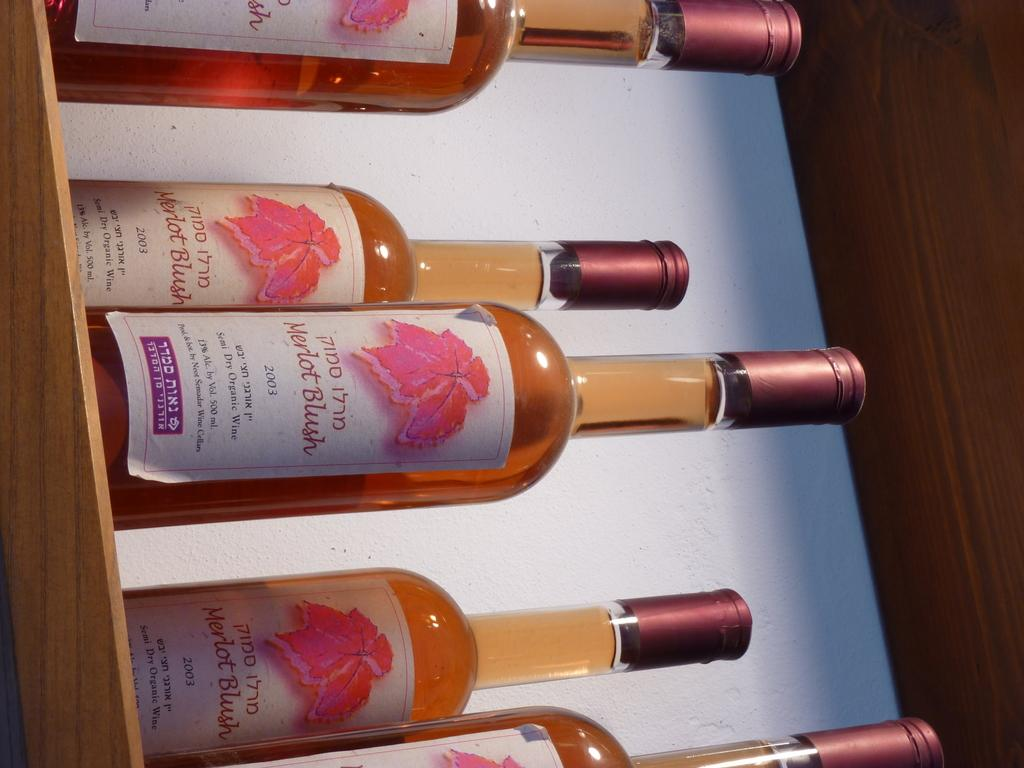<image>
Give a short and clear explanation of the subsequent image. Bottles of wine from 2003 with 13 % alcohol on a shelf. 